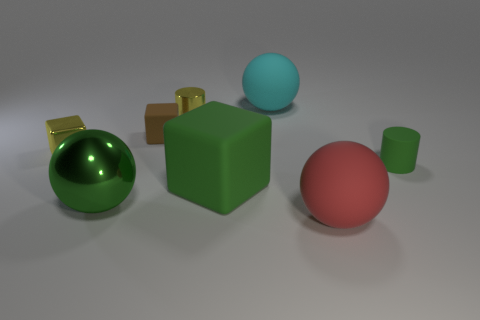Subtract all gray spheres. Subtract all blue cylinders. How many spheres are left? 3 Add 1 small yellow shiny balls. How many objects exist? 9 Subtract all cylinders. How many objects are left? 6 Add 1 small purple metal cylinders. How many small purple metal cylinders exist? 1 Subtract 1 red spheres. How many objects are left? 7 Subtract all balls. Subtract all large gray rubber cylinders. How many objects are left? 5 Add 7 red balls. How many red balls are left? 8 